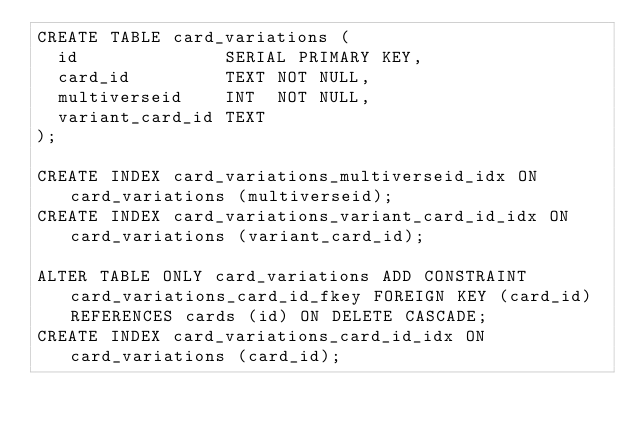<code> <loc_0><loc_0><loc_500><loc_500><_SQL_>CREATE TABLE card_variations (
	id              SERIAL PRIMARY KEY,
	card_id         TEXT NOT NULL,
	multiverseid    INT  NOT NULL,
	variant_card_id TEXT
);

CREATE INDEX card_variations_multiverseid_idx ON card_variations (multiverseid);
CREATE INDEX card_variations_variant_card_id_idx ON card_variations (variant_card_id);

ALTER TABLE ONLY card_variations ADD CONSTRAINT card_variations_card_id_fkey FOREIGN KEY (card_id) REFERENCES cards (id) ON DELETE CASCADE;
CREATE INDEX card_variations_card_id_idx ON card_variations (card_id);
</code> 